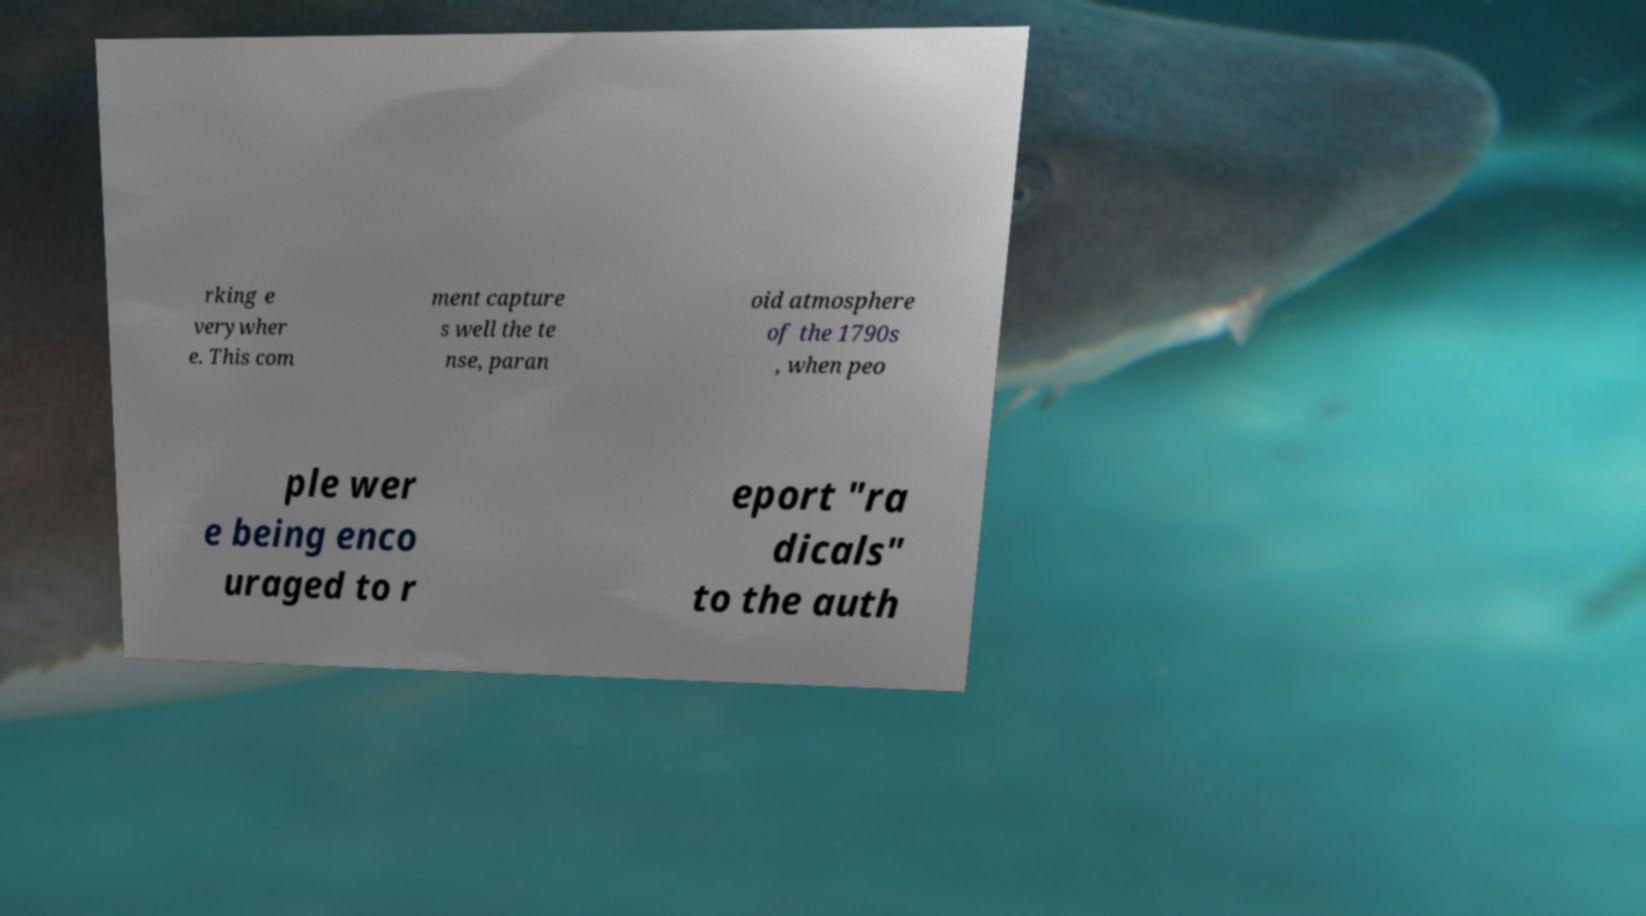Could you assist in decoding the text presented in this image and type it out clearly? rking e verywher e. This com ment capture s well the te nse, paran oid atmosphere of the 1790s , when peo ple wer e being enco uraged to r eport "ra dicals" to the auth 